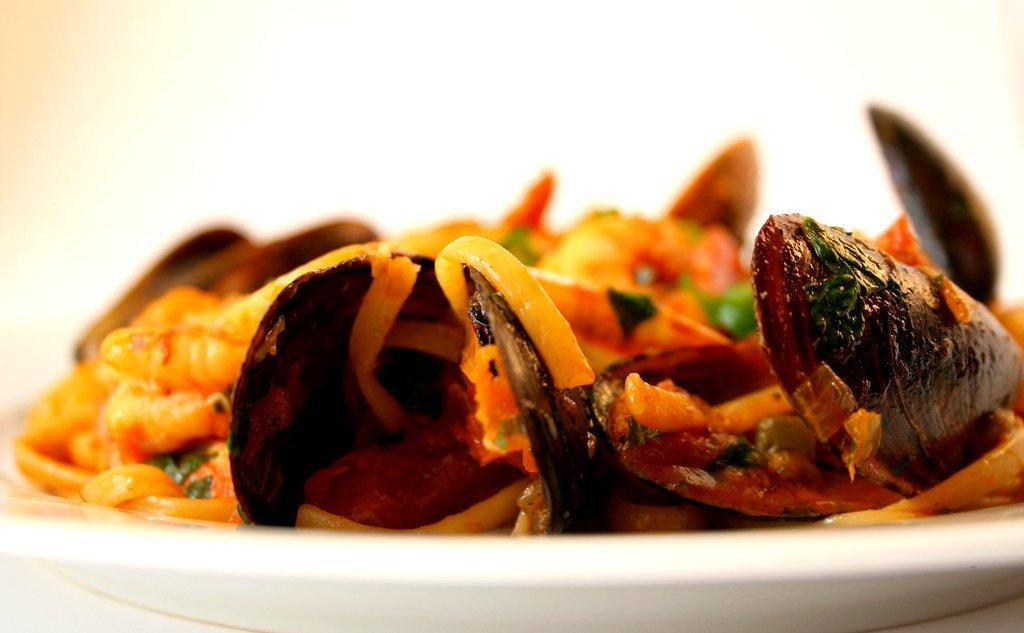What is the color of the plate that holds the food in the image? The plate is white. What colors can be seen in the food? The food has orange and brown colors. Can you describe the background of the image? The background of the image is blurred. Are there any pets visible in the image? No, there are no pets present in the image. What type of plastic material can be seen in the image? There is no plastic material visible in the image. 